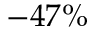Convert formula to latex. <formula><loc_0><loc_0><loc_500><loc_500>- 4 7 \%</formula> 